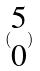<formula> <loc_0><loc_0><loc_500><loc_500>( \begin{matrix} 5 \\ 0 \end{matrix} )</formula> 